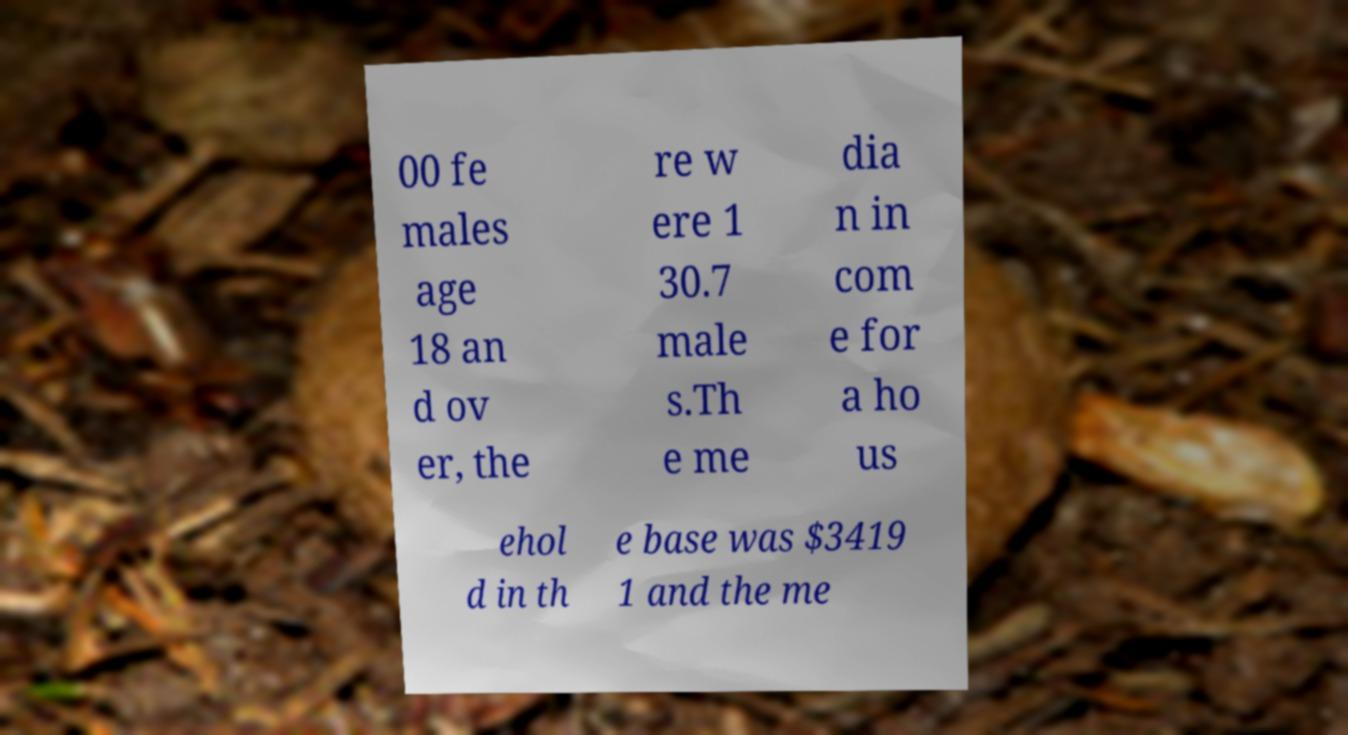Can you read and provide the text displayed in the image?This photo seems to have some interesting text. Can you extract and type it out for me? 00 fe males age 18 an d ov er, the re w ere 1 30.7 male s.Th e me dia n in com e for a ho us ehol d in th e base was $3419 1 and the me 